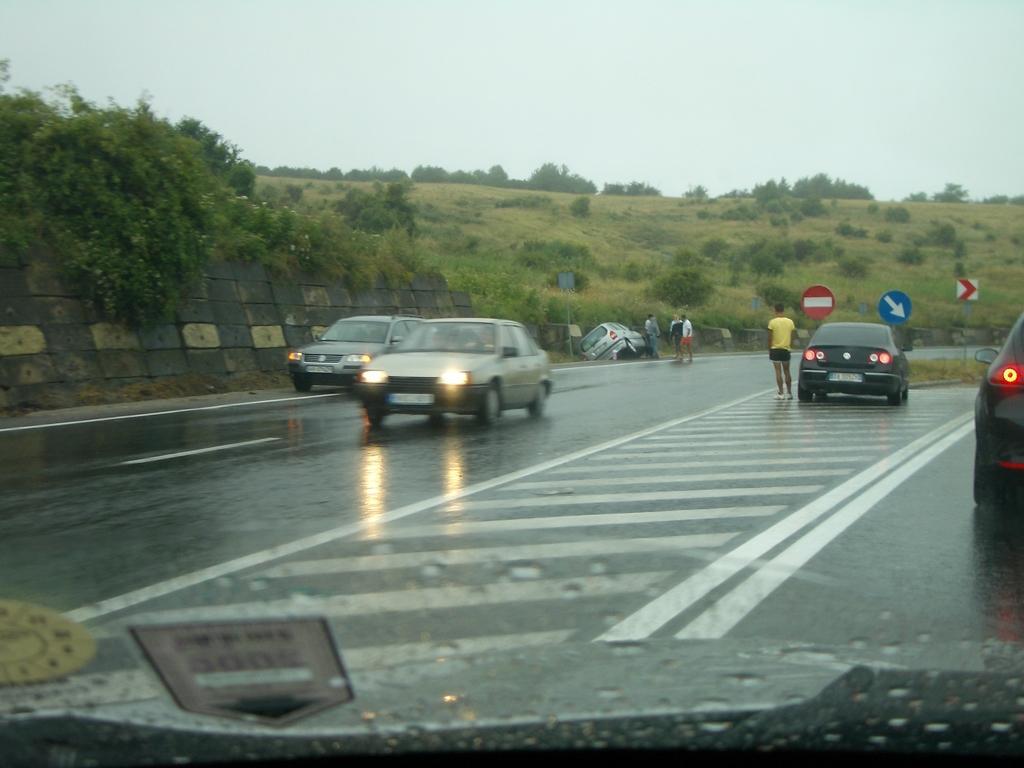Could you give a brief overview of what you see in this image? In this image we can see there are a few moving cars on the road and there are a few people standing on the road and there are few sign boards. In the background there are trees and sky. 